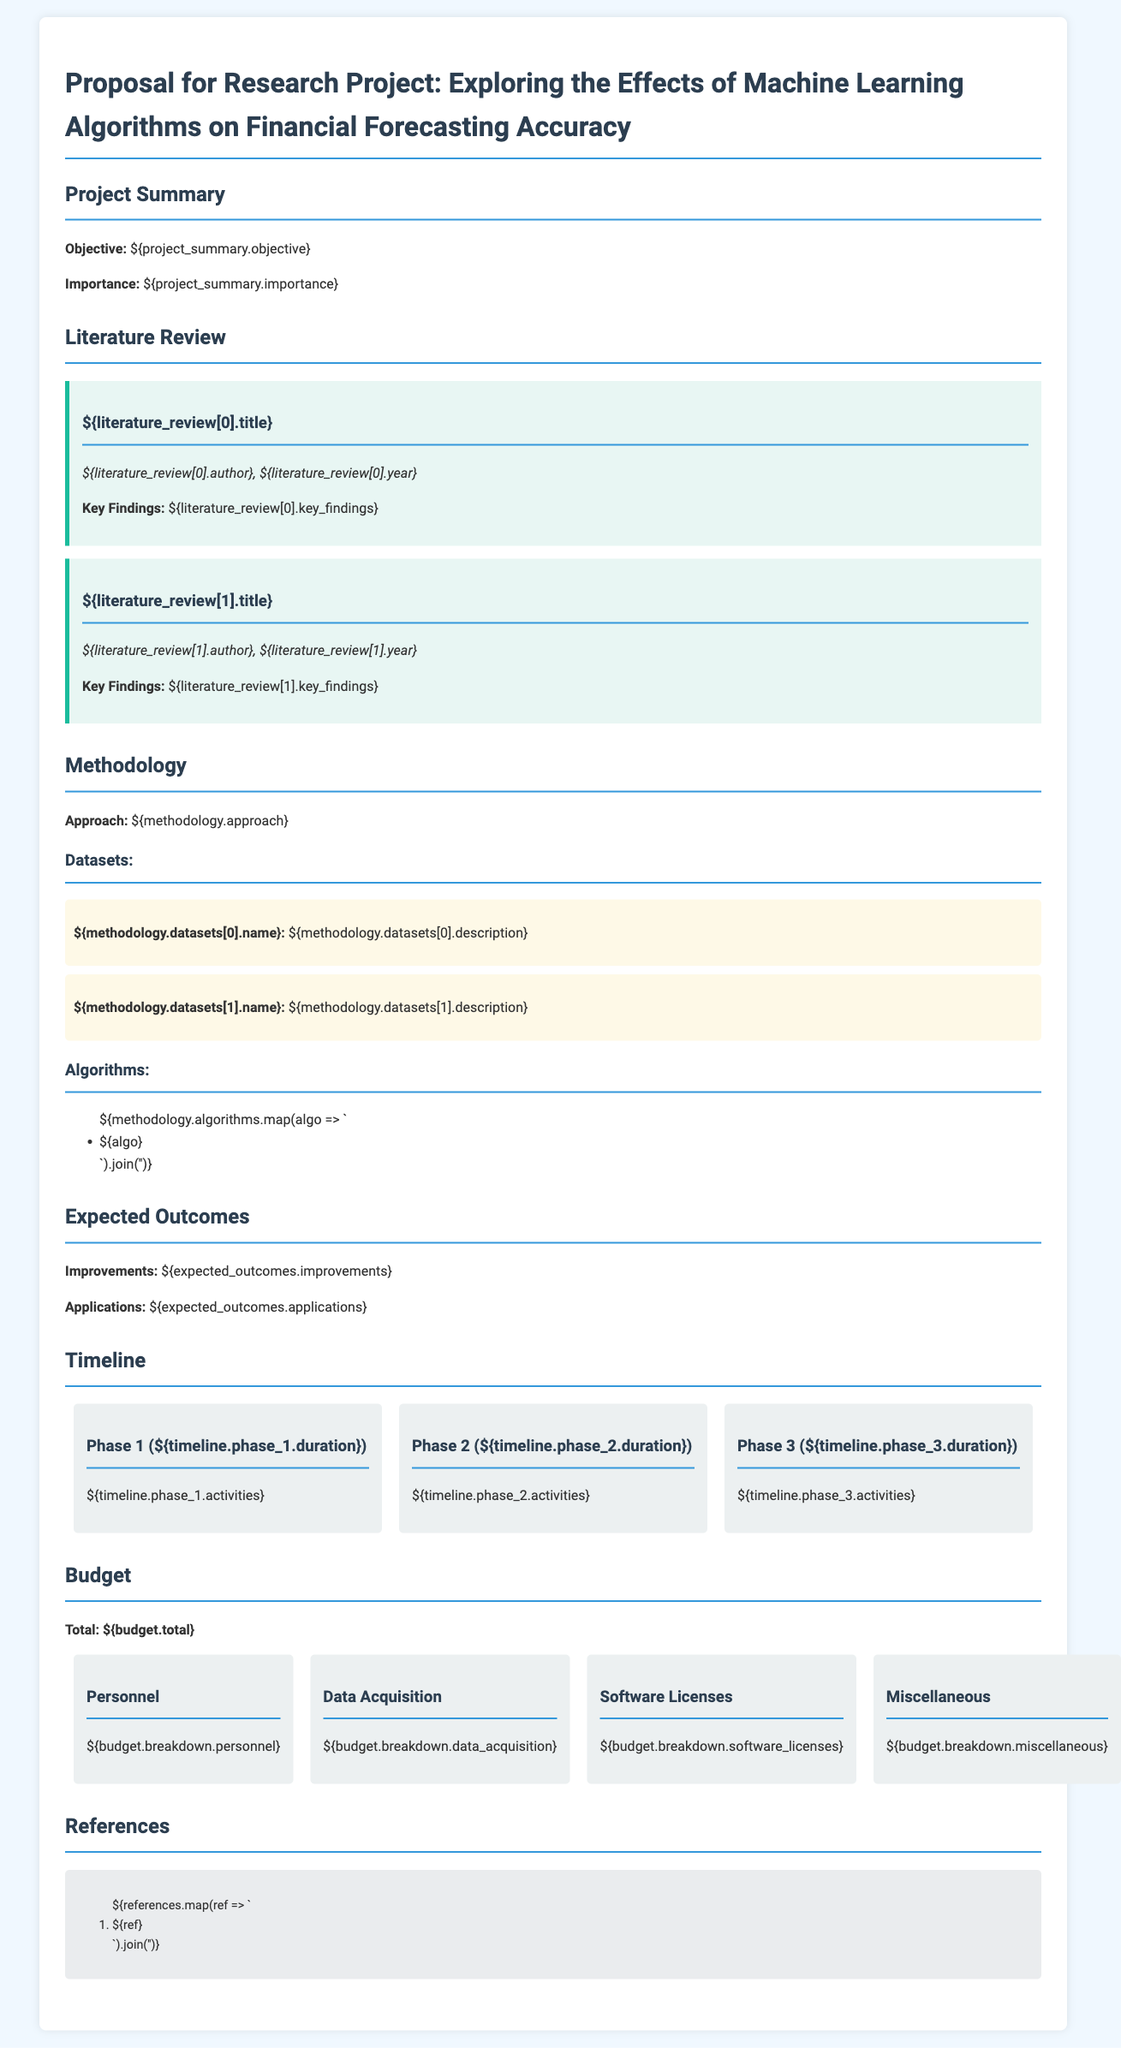What is the objective of the project? The objective is stated in the project summary section of the document.
Answer: Improving financial forecasting accuracy Who authored the first literature reviewed? The author's name is mentioned under the first literature item in the literature review section.
Answer: John Doe What is the total budget for the project? The total budget is specified in the budget section of the document.
Answer: $500,000 How many phases are outlined in the timeline? The number of phases can be counted in the timeline section of the document.
Answer: 3 Which machine learning algorithms are mentioned in the methodology? The algorithms listed in the methodology section are part of the project’s approach.
Answer: Decision Trees, Neural Networks, Support Vector Machines What are the expected applications of the research? Applications are summarized in the expected outcomes section of the document.
Answer: Real-time decision making, risk assessment What duration is assigned to Phase 2? The duration of Phase 2 is detailed in the timeline section.
Answer: 6 months What is one key finding from the second literature reviewed? The key findings from the literature review are highlighted under each literature item.
Answer: Machine learning significantly enhances forecasting precision What are the two datasets described in the methodology? The datasets are mentioned in the methodology section with their descriptions.
Answer: Market Data, Historical Prices 